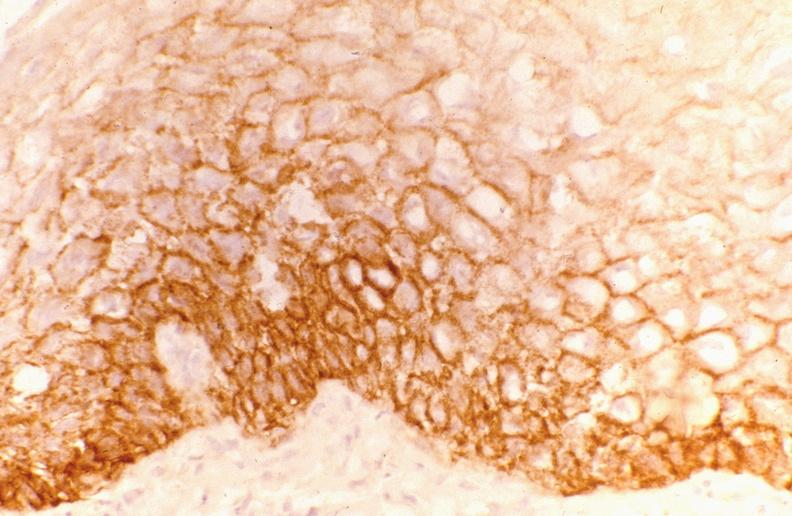where is this from?
Answer the question using a single word or phrase. Gastrointestinal system 